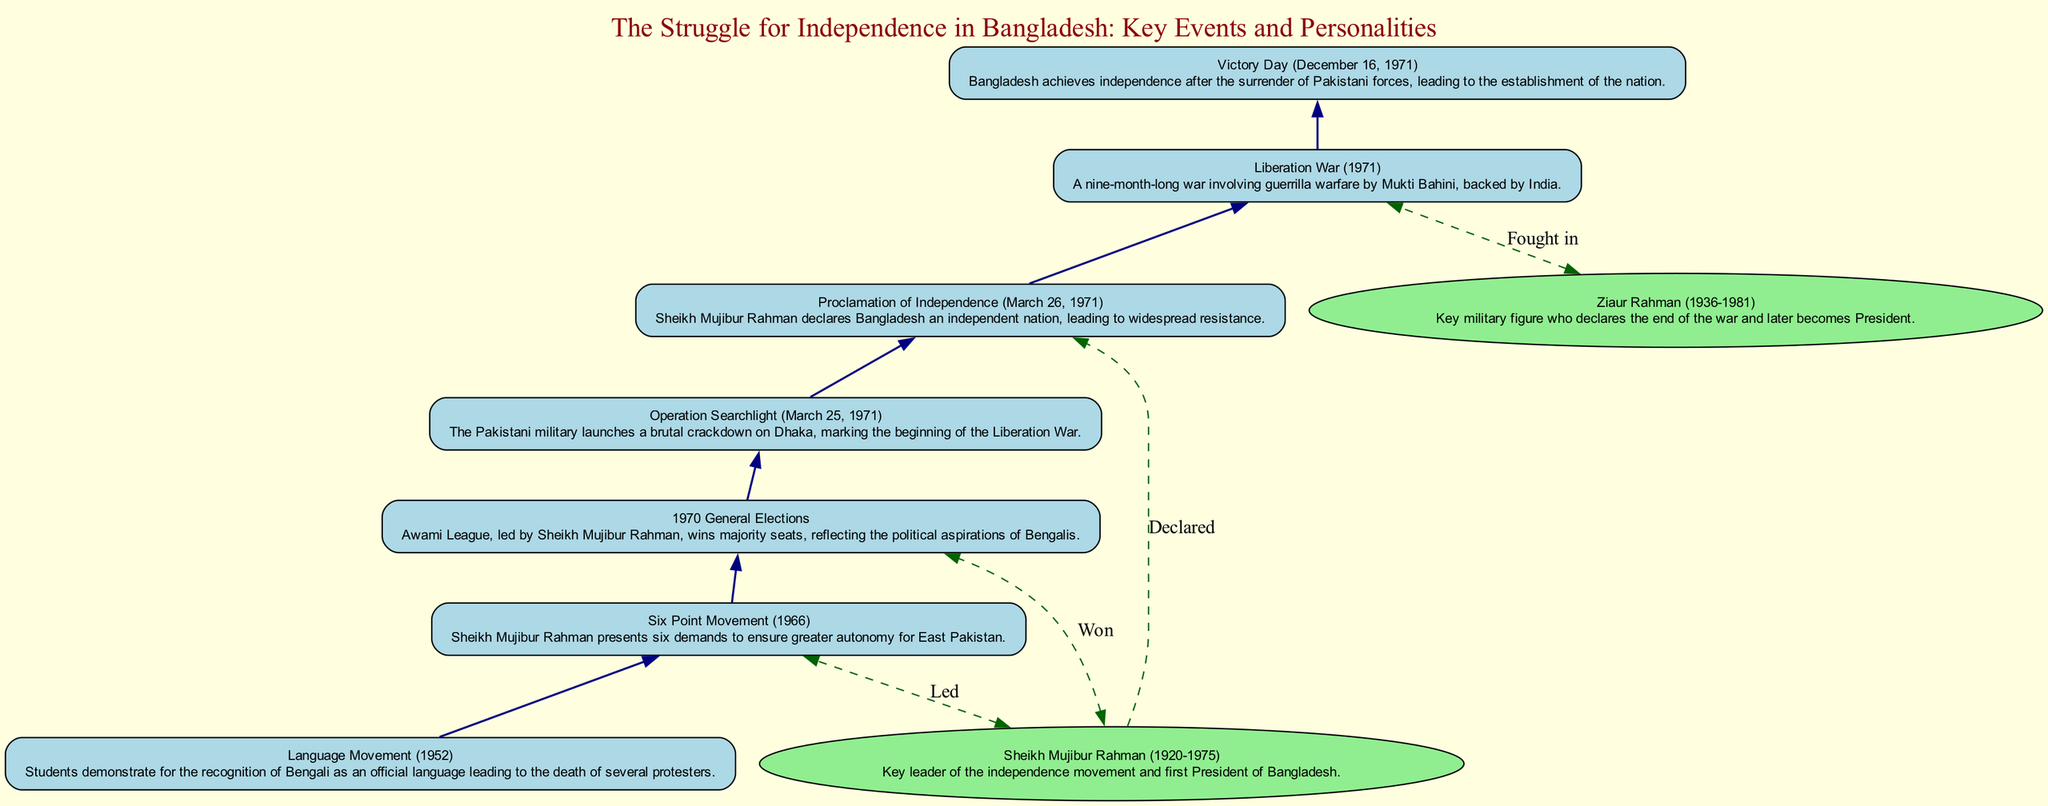What significant event marks the beginning of the Liberation War? The diagram shows "Operation Searchlight (March 25, 1971)" as the event that initiates the war, highlighted as a specific moment where the military crackdown begins.
Answer: Operation Searchlight (March 25, 1971) Who declared Bangladesh as an independent nation? According to the diagram, "Sheikh Mujibur Rahman" is associated with the "Proclamation of Independence (March 26, 1971)," indicating his vital role in declaring independence.
Answer: Sheikh Mujibur Rahman How many key events are listed in the diagram? By counting the events sequentially represented in the diagram, we find a total of seven key events leading up to the independence of Bangladesh.
Answer: 7 Which personality is linked to the 1970 General Elections? The diagram demonstrates a connection from "Sheikh Mujibur Rahman" to the "1970 General Elections," indicating his significance in winning a majority of seats during this political event.
Answer: Sheikh Mujibur Rahman What event followed the Six Point Movement in the diagram's timeline? The diagram presents "1970 General Elections" directly after "Six Point Movement (1966)," establishing a chronological progression between these two events.
Answer: 1970 General Elections What does the dashed line from Sheikh Mujibur Rahman to the Proclamation of Independence indicate? The dashed line signifies a direct relationship where Sheikh Mujibur Rahman is responsible for declaring independence, emphasizing his leadership role in that event.
Answer: Declared What relationship does Ziaur Rahman have with the Liberation War according to the diagram? The connection between "Ziaur Rahman" and the "Liberation War (1971)" is depicted through a dashed line, suggesting his involvement in the conflict, specifically noting him as a key military figure.
Answer: Fought in Which event signifies Victory Day in the timeline? The final event shown in the diagram is "Victory Day (December 16, 1971)", representing the culmination of the independence struggle with the surrender of Pakistani forces.
Answer: Victory Day (December 16, 1971) Which significant movement led to the recognition of Bengali as an official language? The diagram indicates that the "Language Movement (1952)" is the significant event where students advocated for Bengali, leading to several deaths among protesters.
Answer: Language Movement (1952) 